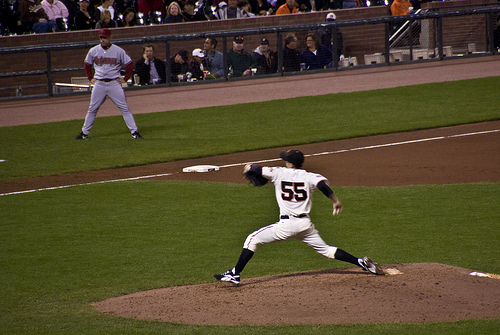What is the hat on? The hat is on the pitcher who is in the middle of his pitching motion on the mound. 